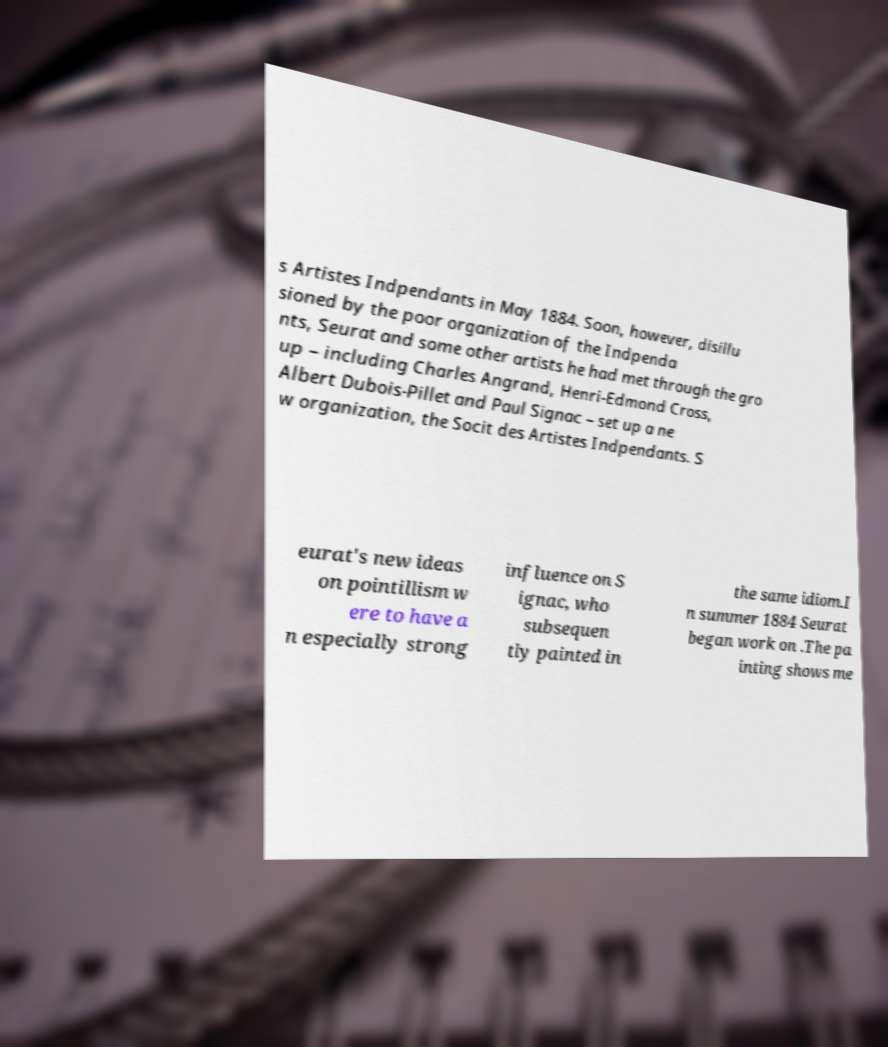Please identify and transcribe the text found in this image. s Artistes Indpendants in May 1884. Soon, however, disillu sioned by the poor organization of the Indpenda nts, Seurat and some other artists he had met through the gro up – including Charles Angrand, Henri-Edmond Cross, Albert Dubois-Pillet and Paul Signac – set up a ne w organization, the Socit des Artistes Indpendants. S eurat's new ideas on pointillism w ere to have a n especially strong influence on S ignac, who subsequen tly painted in the same idiom.I n summer 1884 Seurat began work on .The pa inting shows me 